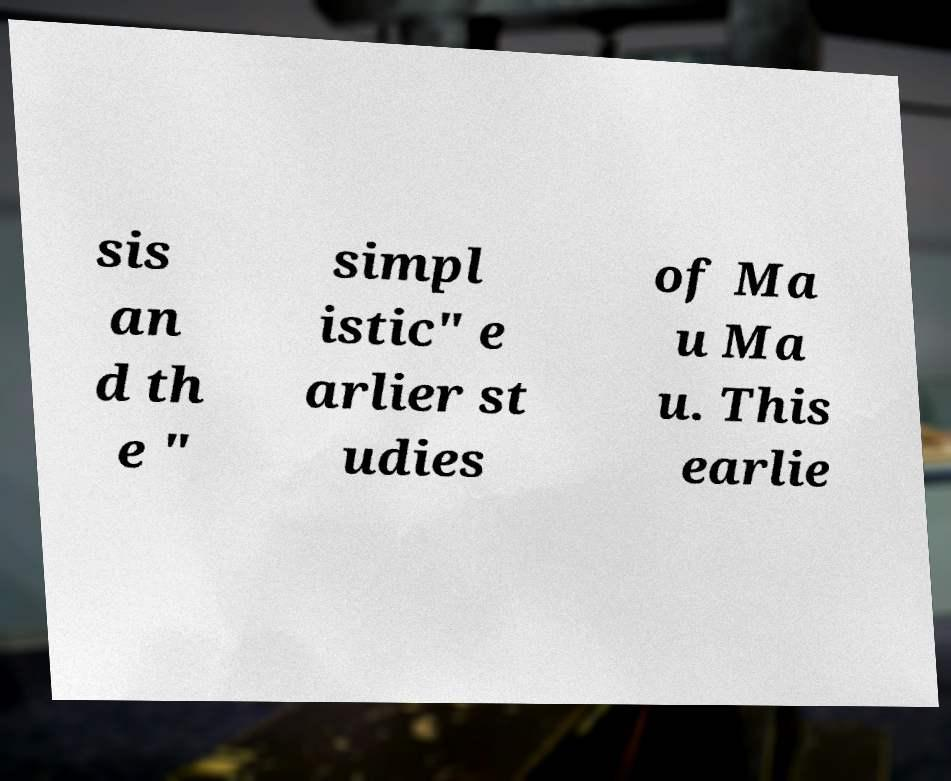I need the written content from this picture converted into text. Can you do that? sis an d th e " simpl istic" e arlier st udies of Ma u Ma u. This earlie 